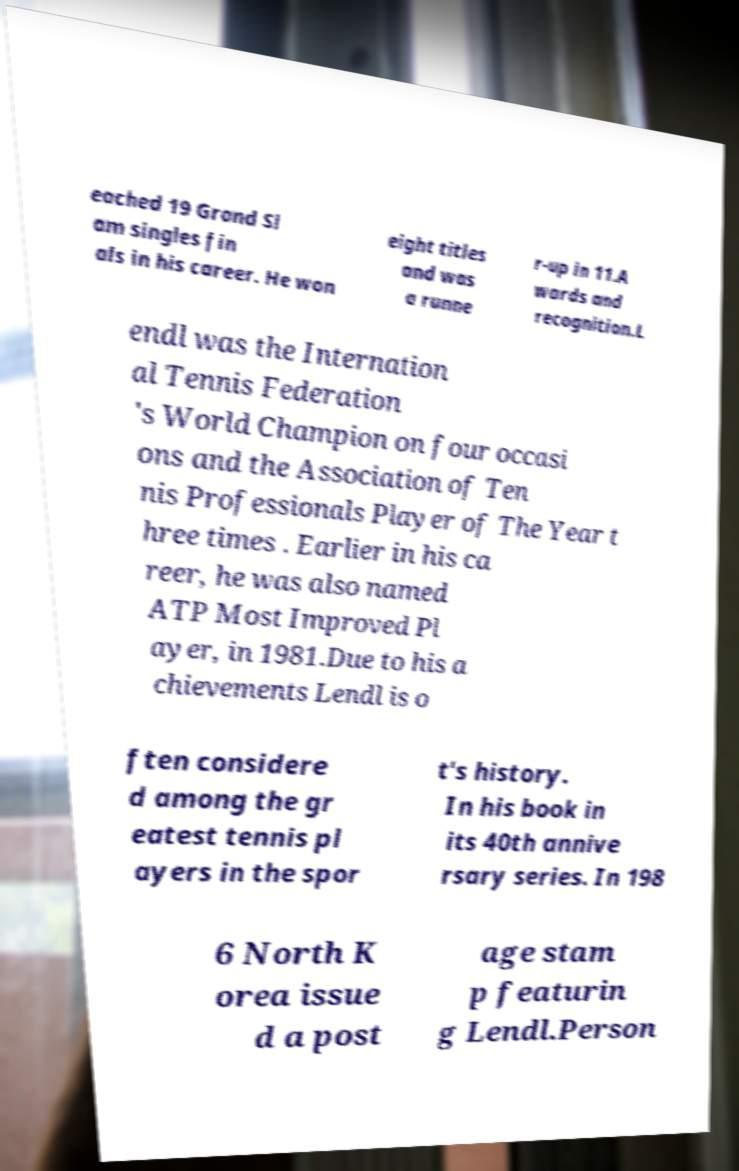For documentation purposes, I need the text within this image transcribed. Could you provide that? eached 19 Grand Sl am singles fin als in his career. He won eight titles and was a runne r-up in 11.A wards and recognition.L endl was the Internation al Tennis Federation 's World Champion on four occasi ons and the Association of Ten nis Professionals Player of The Year t hree times . Earlier in his ca reer, he was also named ATP Most Improved Pl ayer, in 1981.Due to his a chievements Lendl is o ften considere d among the gr eatest tennis pl ayers in the spor t's history. In his book in its 40th annive rsary series. In 198 6 North K orea issue d a post age stam p featurin g Lendl.Person 